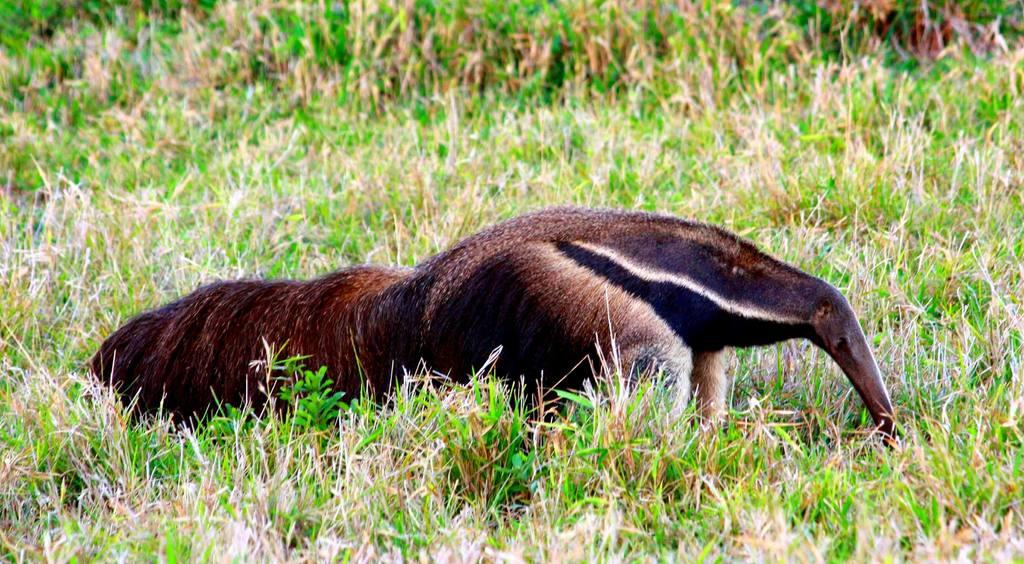What type of creature can be seen in the image? There is an animal in the image. Where is the animal located in the image? The animal is on the ground. What color is the animal in the image? The animal is in brown color. What type of vegetation is present on the ground in the image? There is grass on the ground in the image. What can be seen in the background of the image? There is grass visible in the background of the image. What type of authority does the animal have in the image? The image does not depict any authority figures or situations, so it is not possible to determine the animal's authority. 